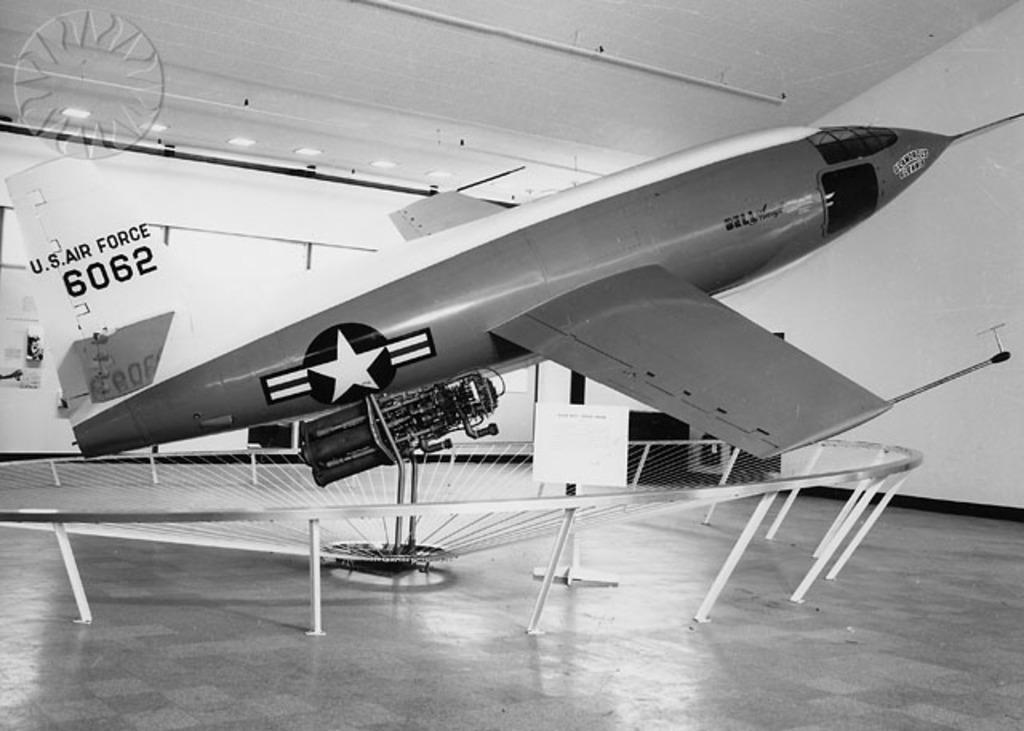Could you give a brief overview of what you see in this image? In this image I can see an airplane. In the background I can see lights on the ceiling and wall. This image is black and white in color. 